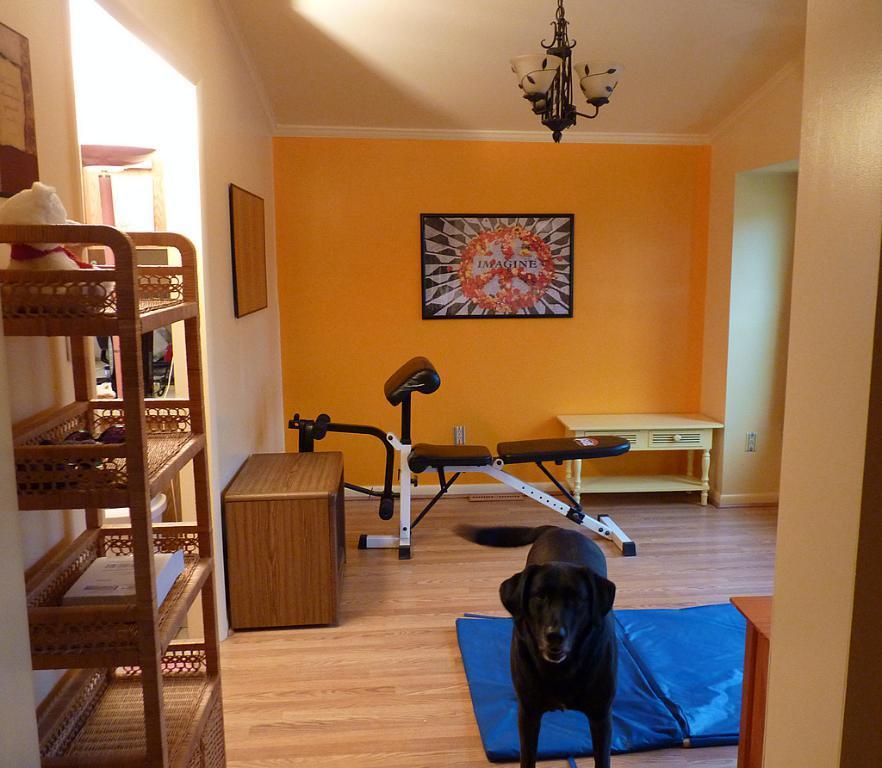Describe this image in one or two sentences. In this image we can see a dog which is black in color, in the foreground of the image there are some tables, shelves in which there are some objects and in the background of the image there is table, gym equipment and some paintings attached to the wall. 